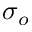<formula> <loc_0><loc_0><loc_500><loc_500>\sigma _ { o }</formula> 